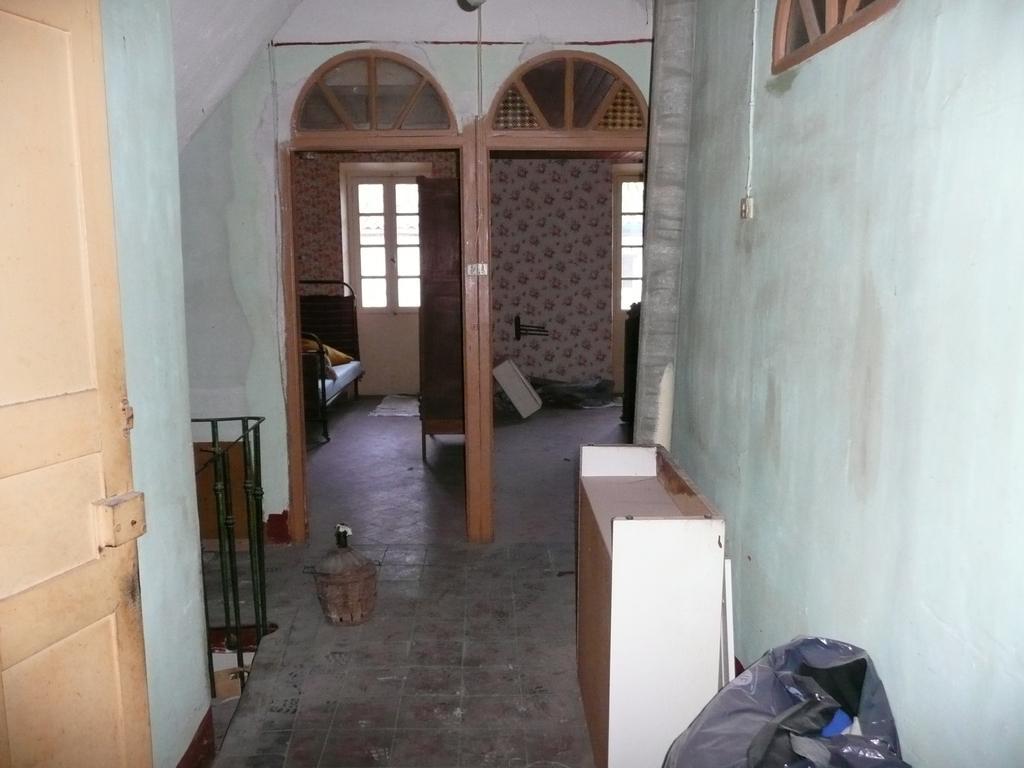Could you give a brief overview of what you see in this image? In this picture I can see an inner view of a room. Here I can see for windows, a bed, a door and some objects of the floor. On the right side I can see a wall and wooden object. 